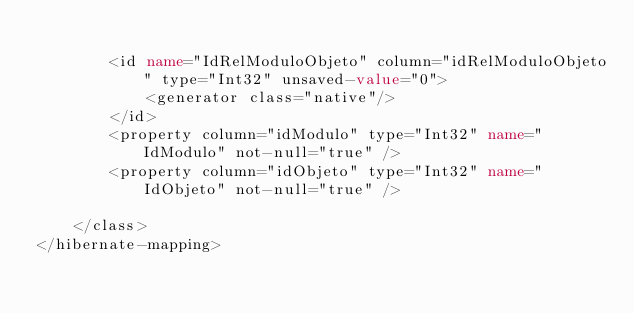Convert code to text. <code><loc_0><loc_0><loc_500><loc_500><_XML_>
		<id name="IdRelModuloObjeto" column="idRelModuloObjeto" type="Int32" unsaved-value="0">
			<generator class="native"/>
		</id>
		<property column="idModulo" type="Int32" name="IdModulo" not-null="true" />
		<property column="idObjeto" type="Int32" name="IdObjeto" not-null="true" />
		
	</class>
</hibernate-mapping>
</code> 